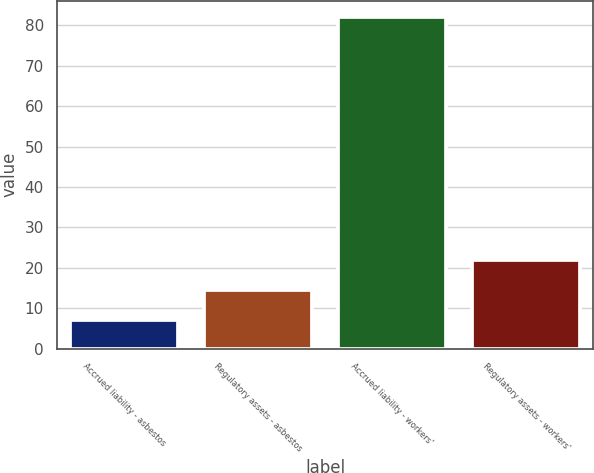Convert chart. <chart><loc_0><loc_0><loc_500><loc_500><bar_chart><fcel>Accrued liability - asbestos<fcel>Regulatory assets - asbestos<fcel>Accrued liability - workers'<fcel>Regulatory assets - workers'<nl><fcel>7<fcel>14.5<fcel>82<fcel>22<nl></chart> 